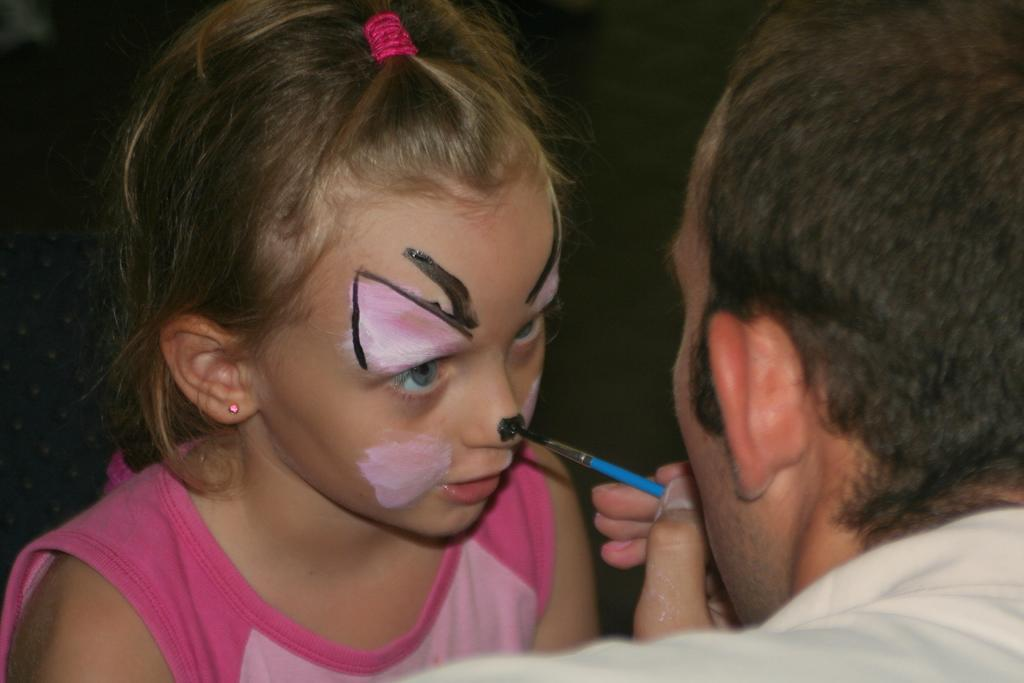Who is present in the image? There is a man and a girl in the image. Where is the man located in the image? The man is towards the right side of the image. What is the man holding in the image? The man is holding a paint brush. Where is the girl located in the image? The girl is towards the bottom of the image. What can be said about the background of the image? The background of the image is dark. What type of meat is being prepared by the man in the image? There is no meat or any indication of food preparation in the image; the man is holding a paint brush. 